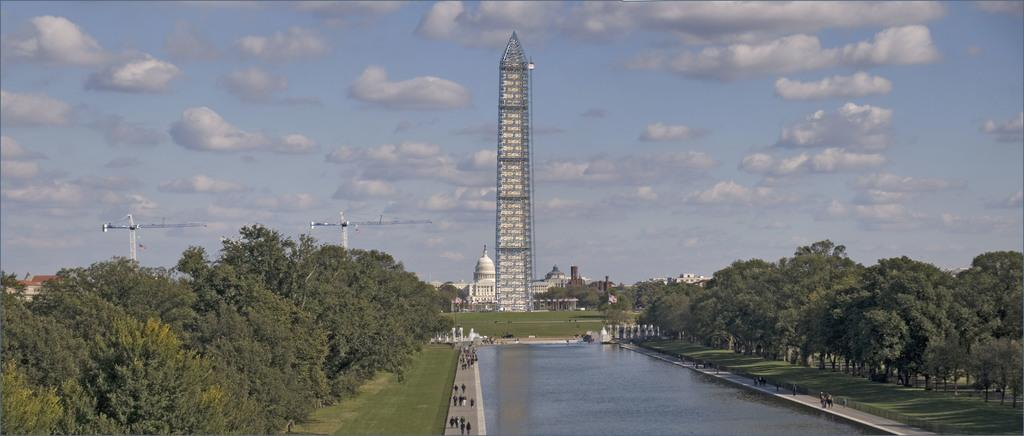How many people are in the image? There is a group of persons in the image. What are the persons in the image doing? The persons are walking on the ground. What type of natural environment is visible in the image? There is water, trees, and grass visible in the image. What type of structure can be seen in the image? There is a tower in the image. What is the condition of the sky in the image? The sky is cloudy in the image. What type of tin can be seen in the image? There is no tin present in the image. Can you tell me how many kitties are playing with the bomb in the image? There are no kitties or bombs present in the image. 